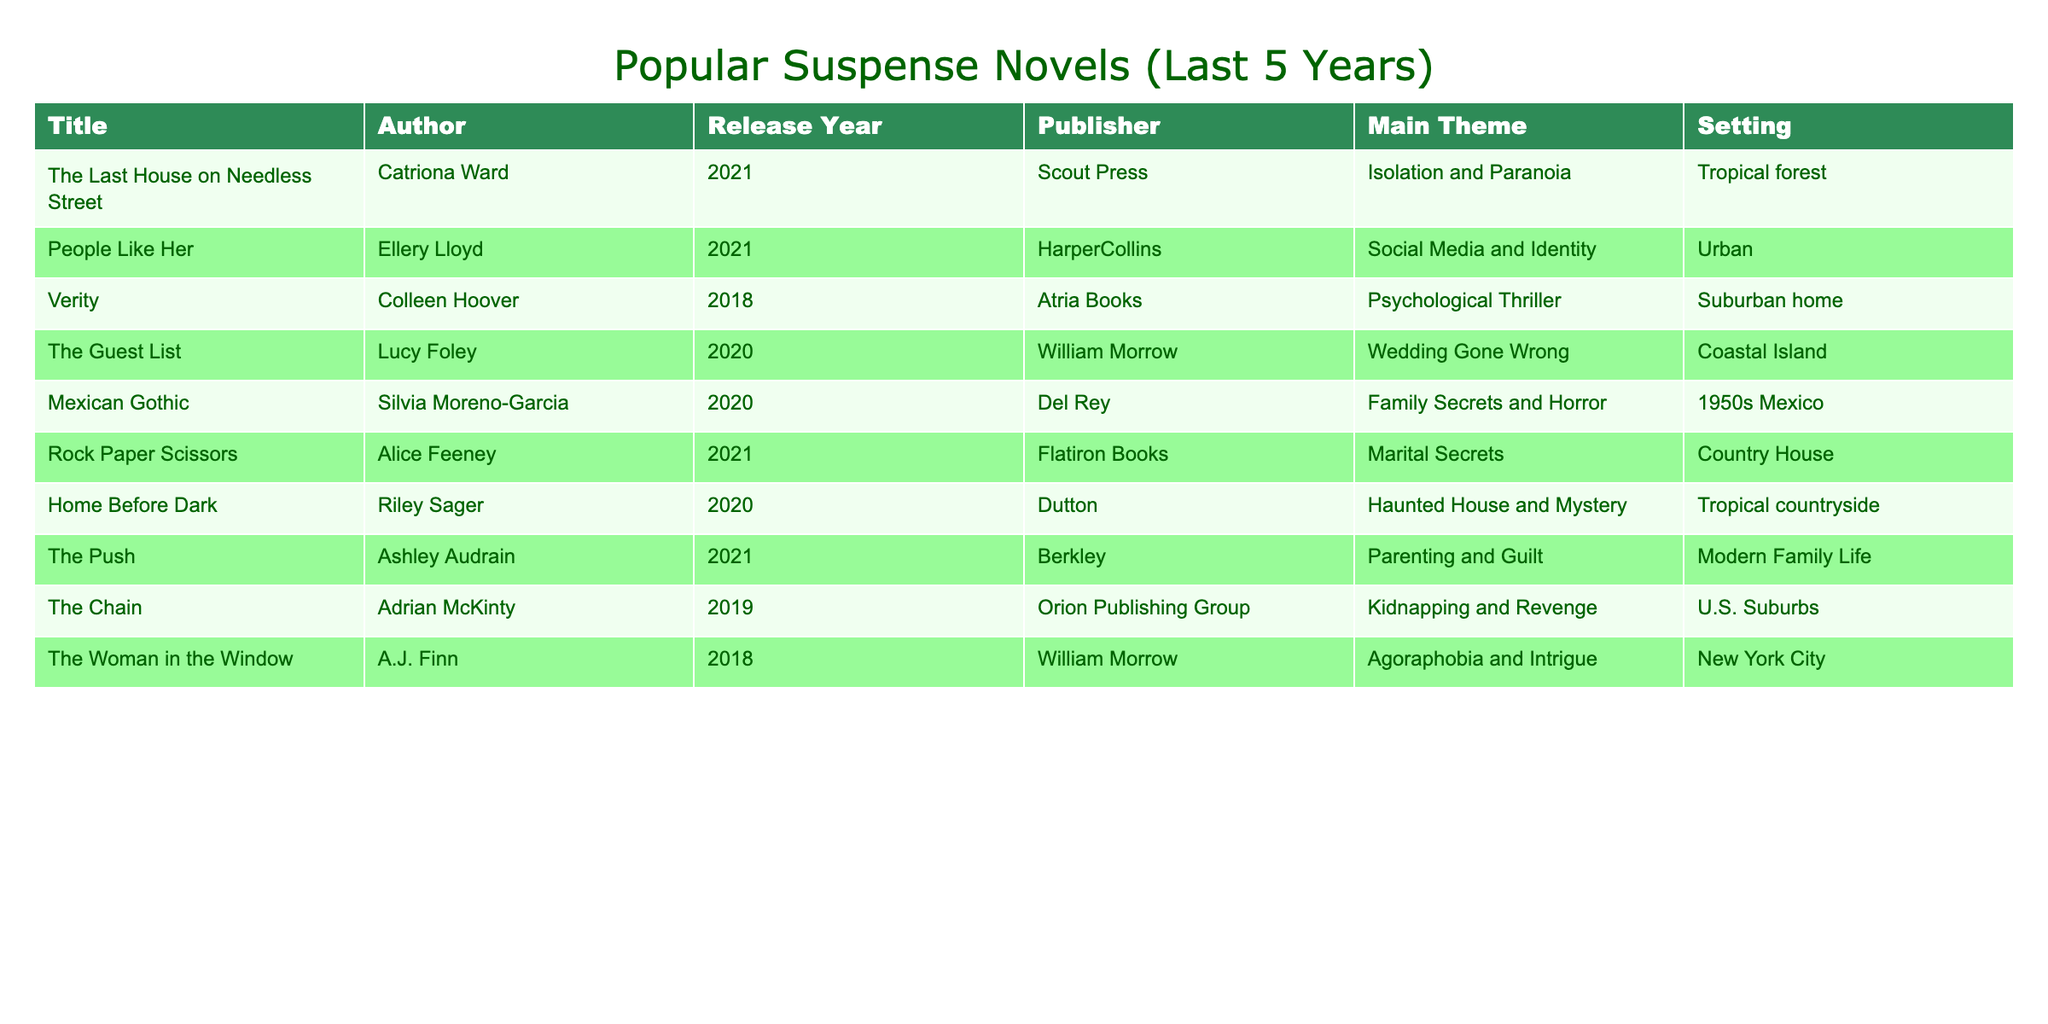What is the most recent suspense novel listed in the table? The most recent release year in the table is 2021, and the titles released that year are "The Last House on Needless Street," "People Like Her," "Rock Paper Scissors," and "The Push." Therefore, any of these titles could be considered the most recent suspense novels.
Answer: The most recent suspense novels are "The Last House on Needless Street," "People Like Her," "Rock Paper Scissors," and "The Push." How many novels are set in a tropical location? By inspecting the "Setting" column, we find that "The Last House on Needless Street" is set in a tropical forest and "Home Before Dark" is set in a tropical countryside. Therefore, there are two novels in tropical settings.
Answer: 2 What is the main theme of "Mexican Gothic"? Referring to the "Main Theme" column, "Mexican Gothic" has a theme of Family Secrets and Horror.
Answer: Family Secrets and Horror Which author has the most published novels in this table? By counting the occurrences of each author in the "Author" column, Catriona Ward, Ellery Lloyd, Colleen Hoover, Lucy Foley, Silvia Moreno-Garcia, Alice Feeney, Riley Sager, and Ashley Audrain are listed only once. Therefore, no author has more than one novel in this table.
Answer: No author has more than one published novel Is "Verity" released in 2021? Referring to the "Release Year" column, "Verity" was released in 2018, not 2021.
Answer: No What is the average release year of the novels listed in the table? The release years are 2021, 2021, 2020, 2020, 2020, 2021, 2020, 2021, 2019, and 2018. To find the average, we sum them up: (2021 + 2021 + 2020 + 2020 + 2020 + 2021 + 2020 + 2021 + 2019 + 2018) = 20200. There are 10 novels, so the average is 20200 / 10 = 2020.
Answer: 2020 How many novels focus on family themes? The novels with themes related to families are "Mexican Gothic," "The Push," and "The Chain." By counting these, we find there are three novels that focus on family themes.
Answer: 3 Is "People Like Her" set in an urban environment? Checking the "Setting" column, "People Like Her" is indeed set in an urban environment.
Answer: Yes Which novel contains a theme of isolation and paranoia? By looking at the "Main Theme" column, "The Last House on Needless Street" has a theme of Isolation and Paranoia.
Answer: The Last House on Needless Street 